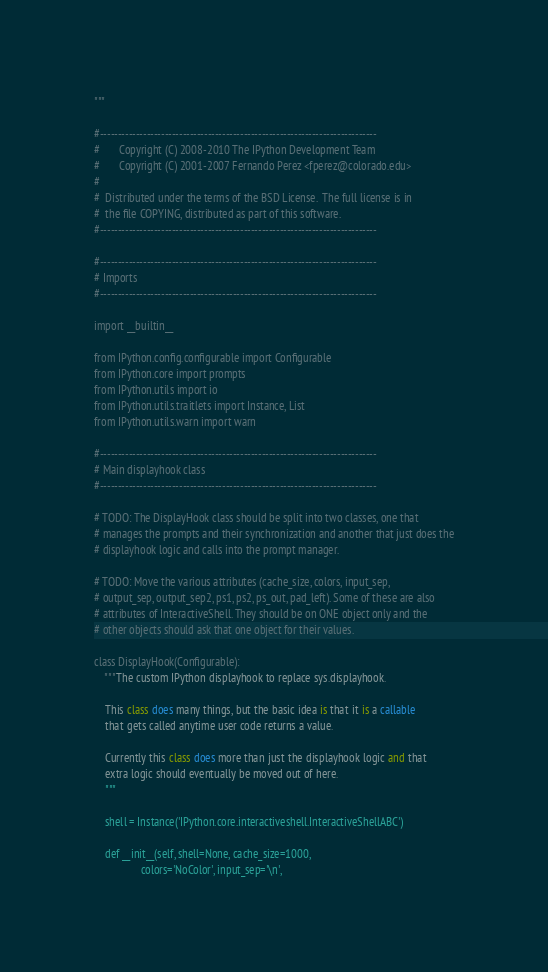<code> <loc_0><loc_0><loc_500><loc_500><_Python_>"""

#-----------------------------------------------------------------------------
#       Copyright (C) 2008-2010 The IPython Development Team
#       Copyright (C) 2001-2007 Fernando Perez <fperez@colorado.edu>
#
#  Distributed under the terms of the BSD License.  The full license is in
#  the file COPYING, distributed as part of this software.
#-----------------------------------------------------------------------------

#-----------------------------------------------------------------------------
# Imports
#-----------------------------------------------------------------------------

import __builtin__

from IPython.config.configurable import Configurable
from IPython.core import prompts
from IPython.utils import io
from IPython.utils.traitlets import Instance, List
from IPython.utils.warn import warn

#-----------------------------------------------------------------------------
# Main displayhook class
#-----------------------------------------------------------------------------

# TODO: The DisplayHook class should be split into two classes, one that
# manages the prompts and their synchronization and another that just does the
# displayhook logic and calls into the prompt manager.

# TODO: Move the various attributes (cache_size, colors, input_sep,
# output_sep, output_sep2, ps1, ps2, ps_out, pad_left). Some of these are also
# attributes of InteractiveShell. They should be on ONE object only and the
# other objects should ask that one object for their values.

class DisplayHook(Configurable):
    """The custom IPython displayhook to replace sys.displayhook.

    This class does many things, but the basic idea is that it is a callable
    that gets called anytime user code returns a value.

    Currently this class does more than just the displayhook logic and that
    extra logic should eventually be moved out of here.
    """

    shell = Instance('IPython.core.interactiveshell.InteractiveShellABC')

    def __init__(self, shell=None, cache_size=1000,
                 colors='NoColor', input_sep='\n',</code> 